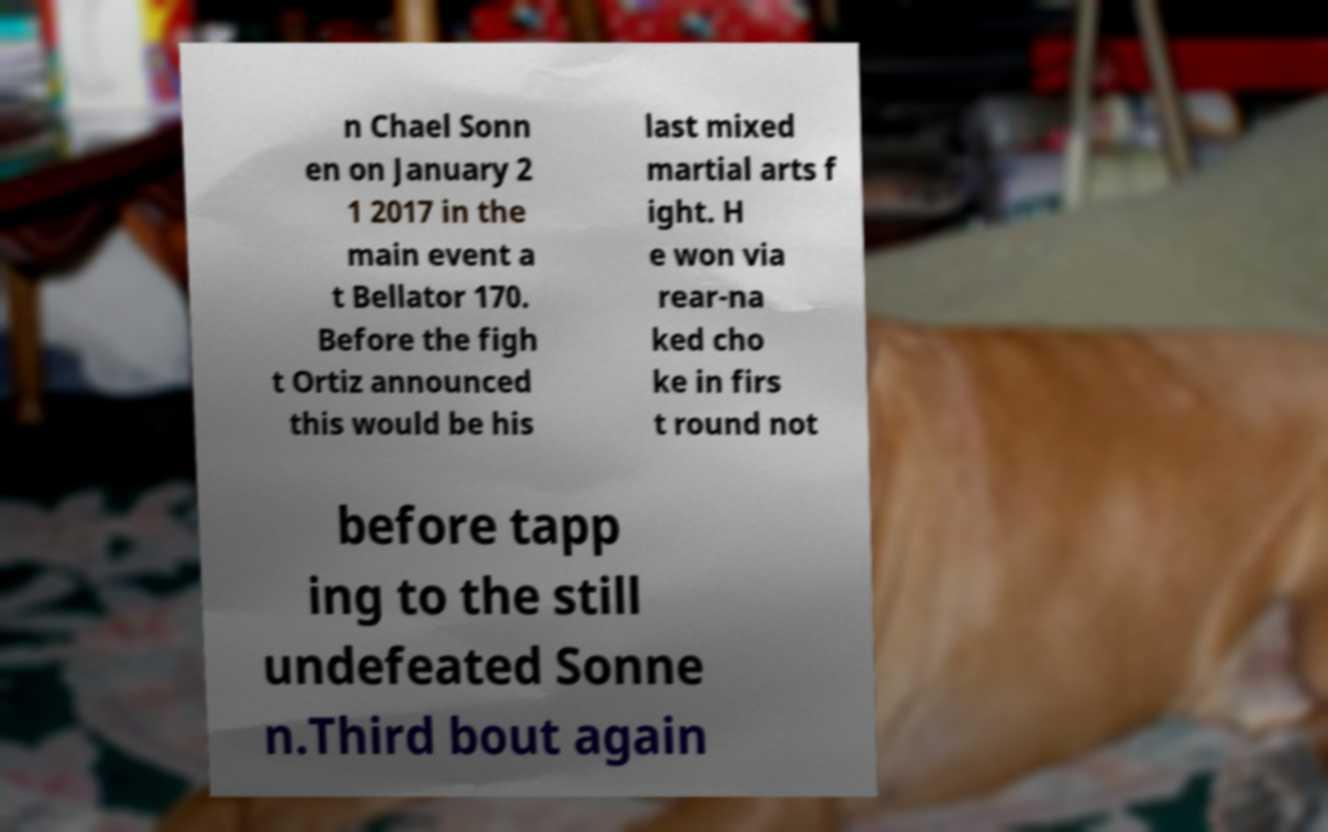What messages or text are displayed in this image? I need them in a readable, typed format. n Chael Sonn en on January 2 1 2017 in the main event a t Bellator 170. Before the figh t Ortiz announced this would be his last mixed martial arts f ight. H e won via rear-na ked cho ke in firs t round not before tapp ing to the still undefeated Sonne n.Third bout again 